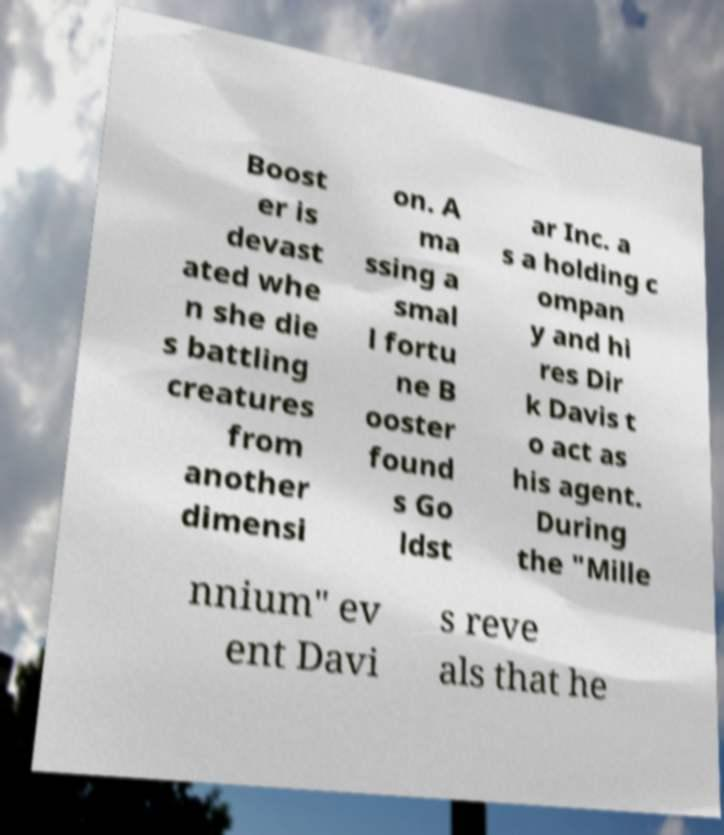What messages or text are displayed in this image? I need them in a readable, typed format. Boost er is devast ated whe n she die s battling creatures from another dimensi on. A ma ssing a smal l fortu ne B ooster found s Go ldst ar Inc. a s a holding c ompan y and hi res Dir k Davis t o act as his agent. During the "Mille nnium" ev ent Davi s reve als that he 